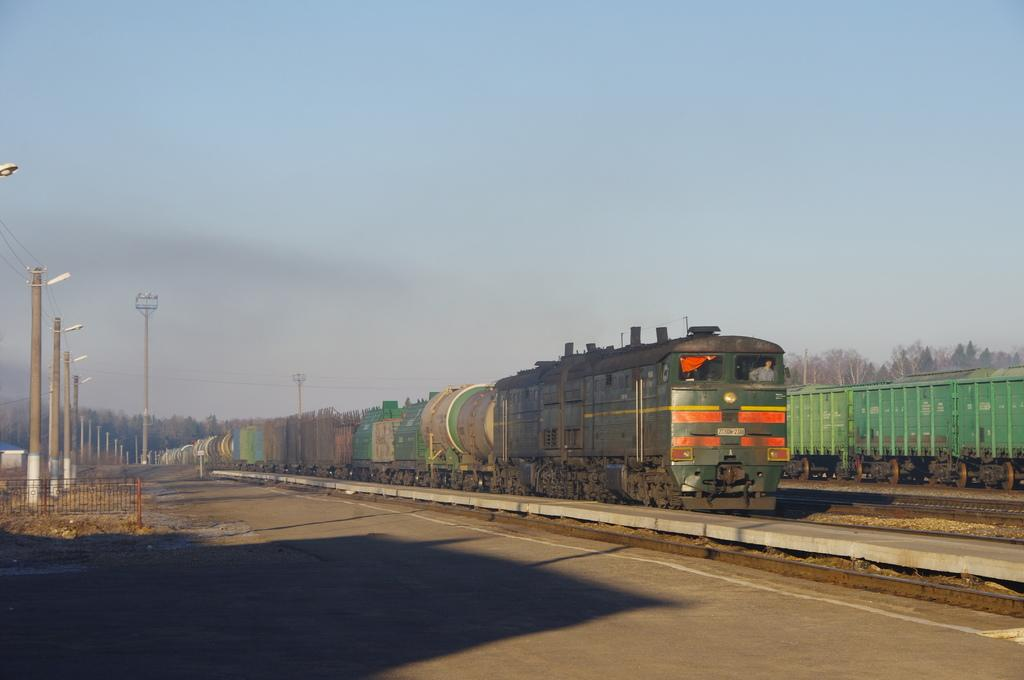What is the main subject of the image? There is a train in the image. Where is the train located? The train is on a train track. What can be seen in the background of the image? There are poles, trees, and plants visible in the image. Are there any other objects in the image besides the train and the mentioned background elements? Yes, there are other unspecified objects in the image. How many uncles are sitting on the train in the image? There is no mention of any uncles in the image, so we cannot determine their presence or number. Can you tell me how many lizards are crawling on the poles in the image? There are no lizards present in the image; only the train, train track, poles, trees, plants, and other unspecified objects are visible. 